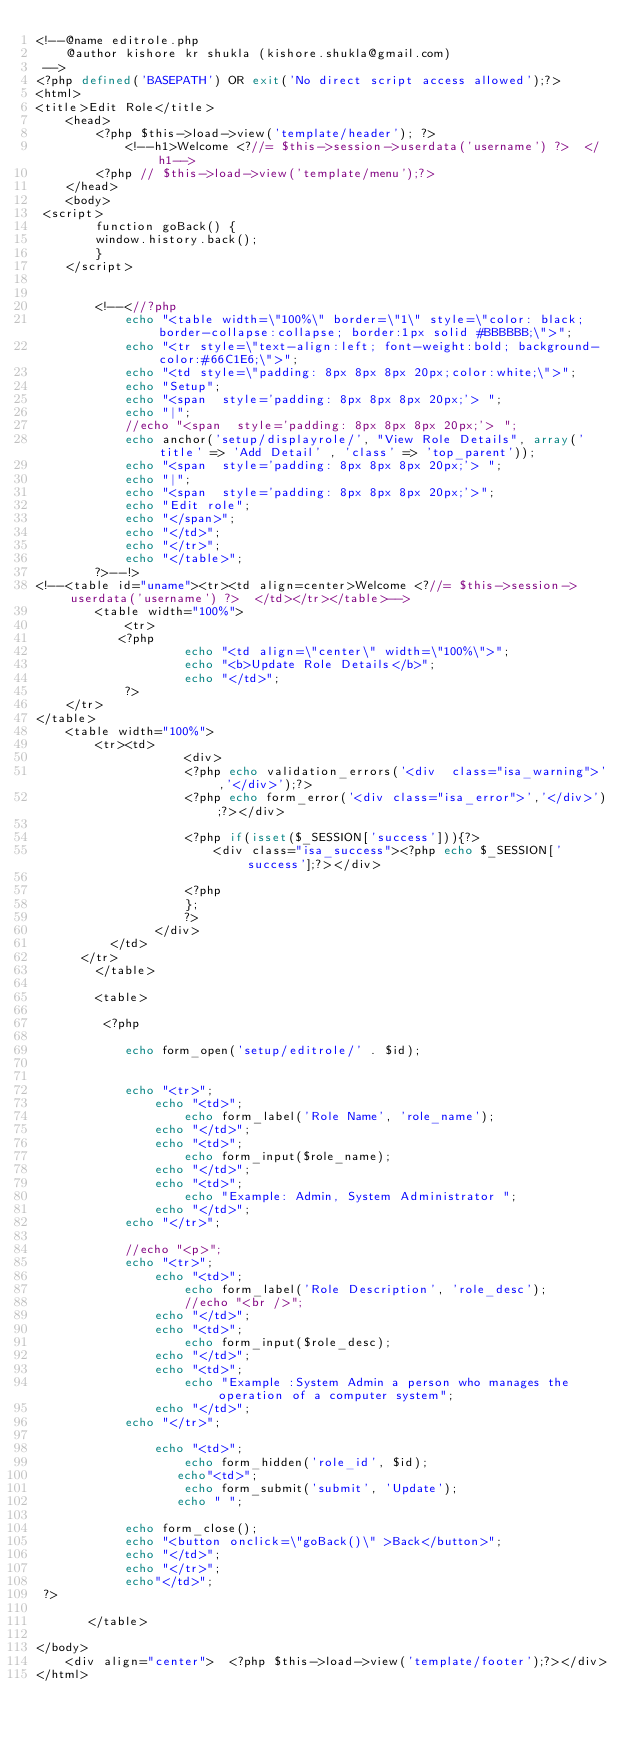Convert code to text. <code><loc_0><loc_0><loc_500><loc_500><_PHP_><!--@name editrole.php
    @author kishore kr shukla (kishore.shukla@gmail.com)
 -->
<?php defined('BASEPATH') OR exit('No direct script access allowed');?>
<html>
<title>Edit Role</title>
    <head>    
        <?php $this->load->view('template/header'); ?>
            <!--h1>Welcome <?//= $this->session->userdata('username') ?>  </h1-->
        <?php // $this->load->view('template/menu');?>
    </head>
    <body>
 <script>
        function goBack() {
        window.history.back();
        }
    </script>


        <!--<//?php
            echo "<table width=\"100%\" border=\"1\" style=\"color: black;  border-collapse:collapse; border:1px solid #BBBBBB;\">";
            echo "<tr style=\"text-align:left; font-weight:bold; background-color:#66C1E6;\">";
            echo "<td style=\"padding: 8px 8px 8px 20px;color:white;\">";
            echo "Setup";
            echo "<span  style='padding: 8px 8px 8px 20px;'> ";
            echo "|";
            //echo "<span  style='padding: 8px 8px 8px 20px;'> ";
            echo anchor('setup/displayrole/', "View Role Details", array('title' => 'Add Detail' , 'class' => 'top_parent'));
            echo "<span  style='padding: 8px 8px 8px 20px;'> ";
            echo "|";
            echo "<span  style='padding: 8px 8px 8px 20px;'>";
            echo "Edit role";
            echo "</span>";
            echo "</td>";
            echo "</tr>";
            echo "</table>";
        ?>--!>
<!--<table id="uname"><tr><td align=center>Welcome <?//= $this->session->userdata('username') ?>  </td></tr></table>-->
        <table width="100%"> 
            <tr>   
           <?php
                    echo "<td align=\"center\" width=\"100%\">";
                    echo "<b>Update Role Details</b>";
                    echo "</td>";
            ?>
	</tr>
</table>
	<table width="100%">
		<tr><td>
              		<div>
                    <?php echo validation_errors('<div  class="isa_warning">','</div>');?>
                    <?php echo form_error('<div class="isa_error">','</div>');?></div>

                    <?php if(isset($_SESSION['success'])){?>
                        <div class="isa_success"><?php echo $_SESSION['success'];?></div>

                    <?php
                    };
                    ?>
                </div> 
	      </td>
	  </tr>  
        </table>
    
        <table>  
 
         <?php

            echo form_open('setup/editrole/' . $id);

       
            echo "<tr>";
                echo "<td>";
                    echo form_label('Role Name', 'role_name');
                echo "</td>";
                echo "<td>";
                    echo form_input($role_name);
                echo "</td>";
                echo "<td>";
                    echo "Example: Admin, System Administrator ";
                echo "</td>";
            echo "</tr>";

            //echo "<p>";
            echo "<tr>";
                echo "<td>";
                    echo form_label('Role Description', 'role_desc');
                    //echo "<br />";
                echo "</td>";
                echo "<td>";
                    echo form_input($role_desc);
                echo "</td>";
                echo "<td>";
                    echo "Example :System Admin a person who manages the operation of a computer system";
                echo "</td>";
            echo "</tr>";
        
                echo "<td>";
                    echo form_hidden('role_id', $id);
                   echo"<td>";
                    echo form_submit('submit', 'Update');
                   echo " ";
       
            echo form_close();
            echo "<button onclick=\"goBack()\" >Back</button>";
            echo "</td>";
            echo "</tr>";
            echo"</td>";
 ?>
 
       </table> 
          
</body>
    <div align="center">  <?php $this->load->view('template/footer');?></div>
</html>



</code> 